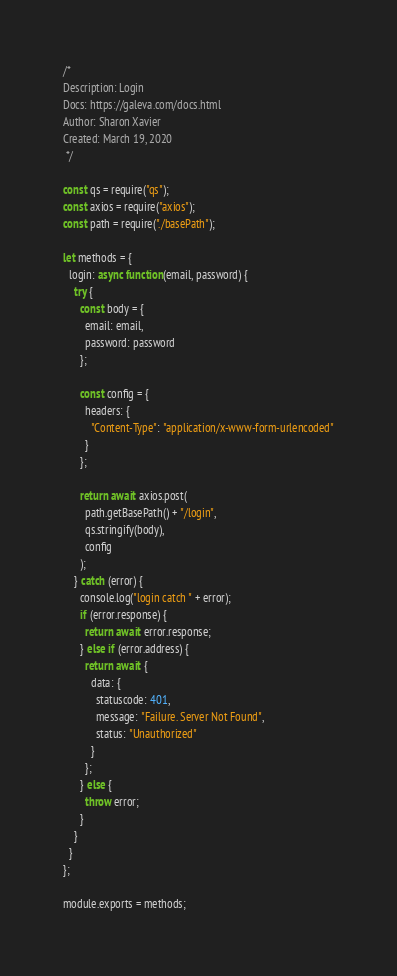Convert code to text. <code><loc_0><loc_0><loc_500><loc_500><_JavaScript_>/* 
Description: Login
Docs: https://galeva.com/docs.html
Author: Sharon Xavier
Created: March 19, 2020
 */

const qs = require("qs");
const axios = require("axios");
const path = require("./basePath");

let methods = {
  login: async function(email, password) {
    try {
      const body = {
        email: email,
        password: password
      };

      const config = {
        headers: {
          "Content-Type": "application/x-www-form-urlencoded"
        }
      };

      return await axios.post(
        path.getBasePath() + "/login",
        qs.stringify(body),
        config
      );
    } catch (error) {
      console.log("login catch " + error);
      if (error.response) {
        return await error.response;
      } else if (error.address) {
        return await {
          data: {
            statuscode: 401,
            message: "Failure. Server Not Found",
            status: "Unauthorized"
          }
        };
      } else {
        throw error;
      }
    }
  }
};

module.exports = methods;
</code> 